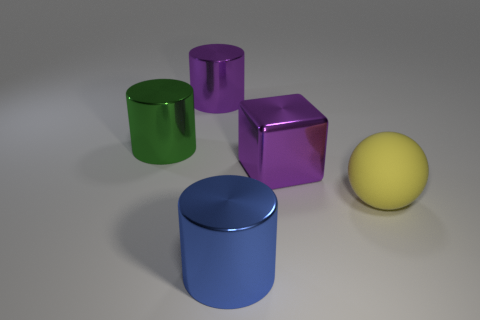Is there any other thing that is the same material as the yellow object?
Offer a very short reply. No. What is the color of the cube that is made of the same material as the large blue cylinder?
Keep it short and to the point. Purple. What is the shape of the green thing?
Make the answer very short. Cylinder. How many large metal things are the same color as the big shiny block?
Provide a short and direct response. 1. How many big blue metal objects are to the right of the big cylinder in front of the yellow sphere?
Provide a succinct answer. 0. How many spheres are either small green matte things or yellow matte objects?
Ensure brevity in your answer.  1. Is there a large blue metallic object?
Your response must be concise. Yes. There is a blue object that is the same shape as the green shiny thing; what is its size?
Ensure brevity in your answer.  Large. The purple shiny thing to the left of the large metal thing that is in front of the big yellow sphere is what shape?
Offer a very short reply. Cylinder. How many gray things are either cylinders or shiny cubes?
Your answer should be very brief. 0. 